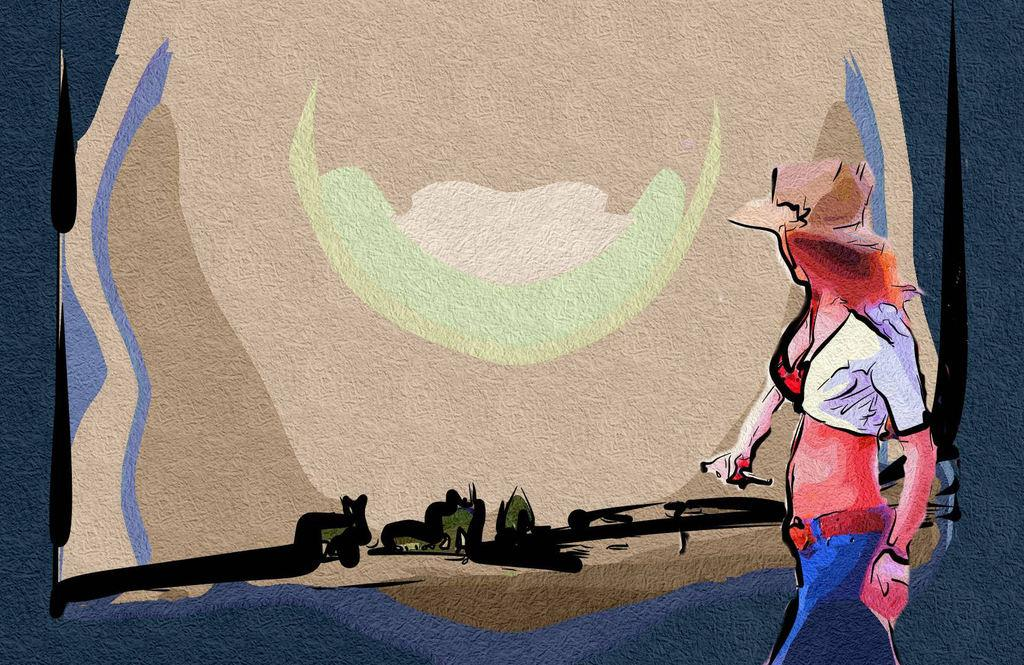What type of artwork is depicted in the image? The image is a painting. Can you describe the subject of the painting? There is a person in the painting. What is the person in the painting doing? The person is walking towards the left side of the painting. What type of attraction can be seen in the background of the painting? There is no attraction visible in the background of the painting; it only features a person walking. What kind of feast is being prepared by the person in the painting? There is no feast being prepared in the painting; the person is simply walking. 